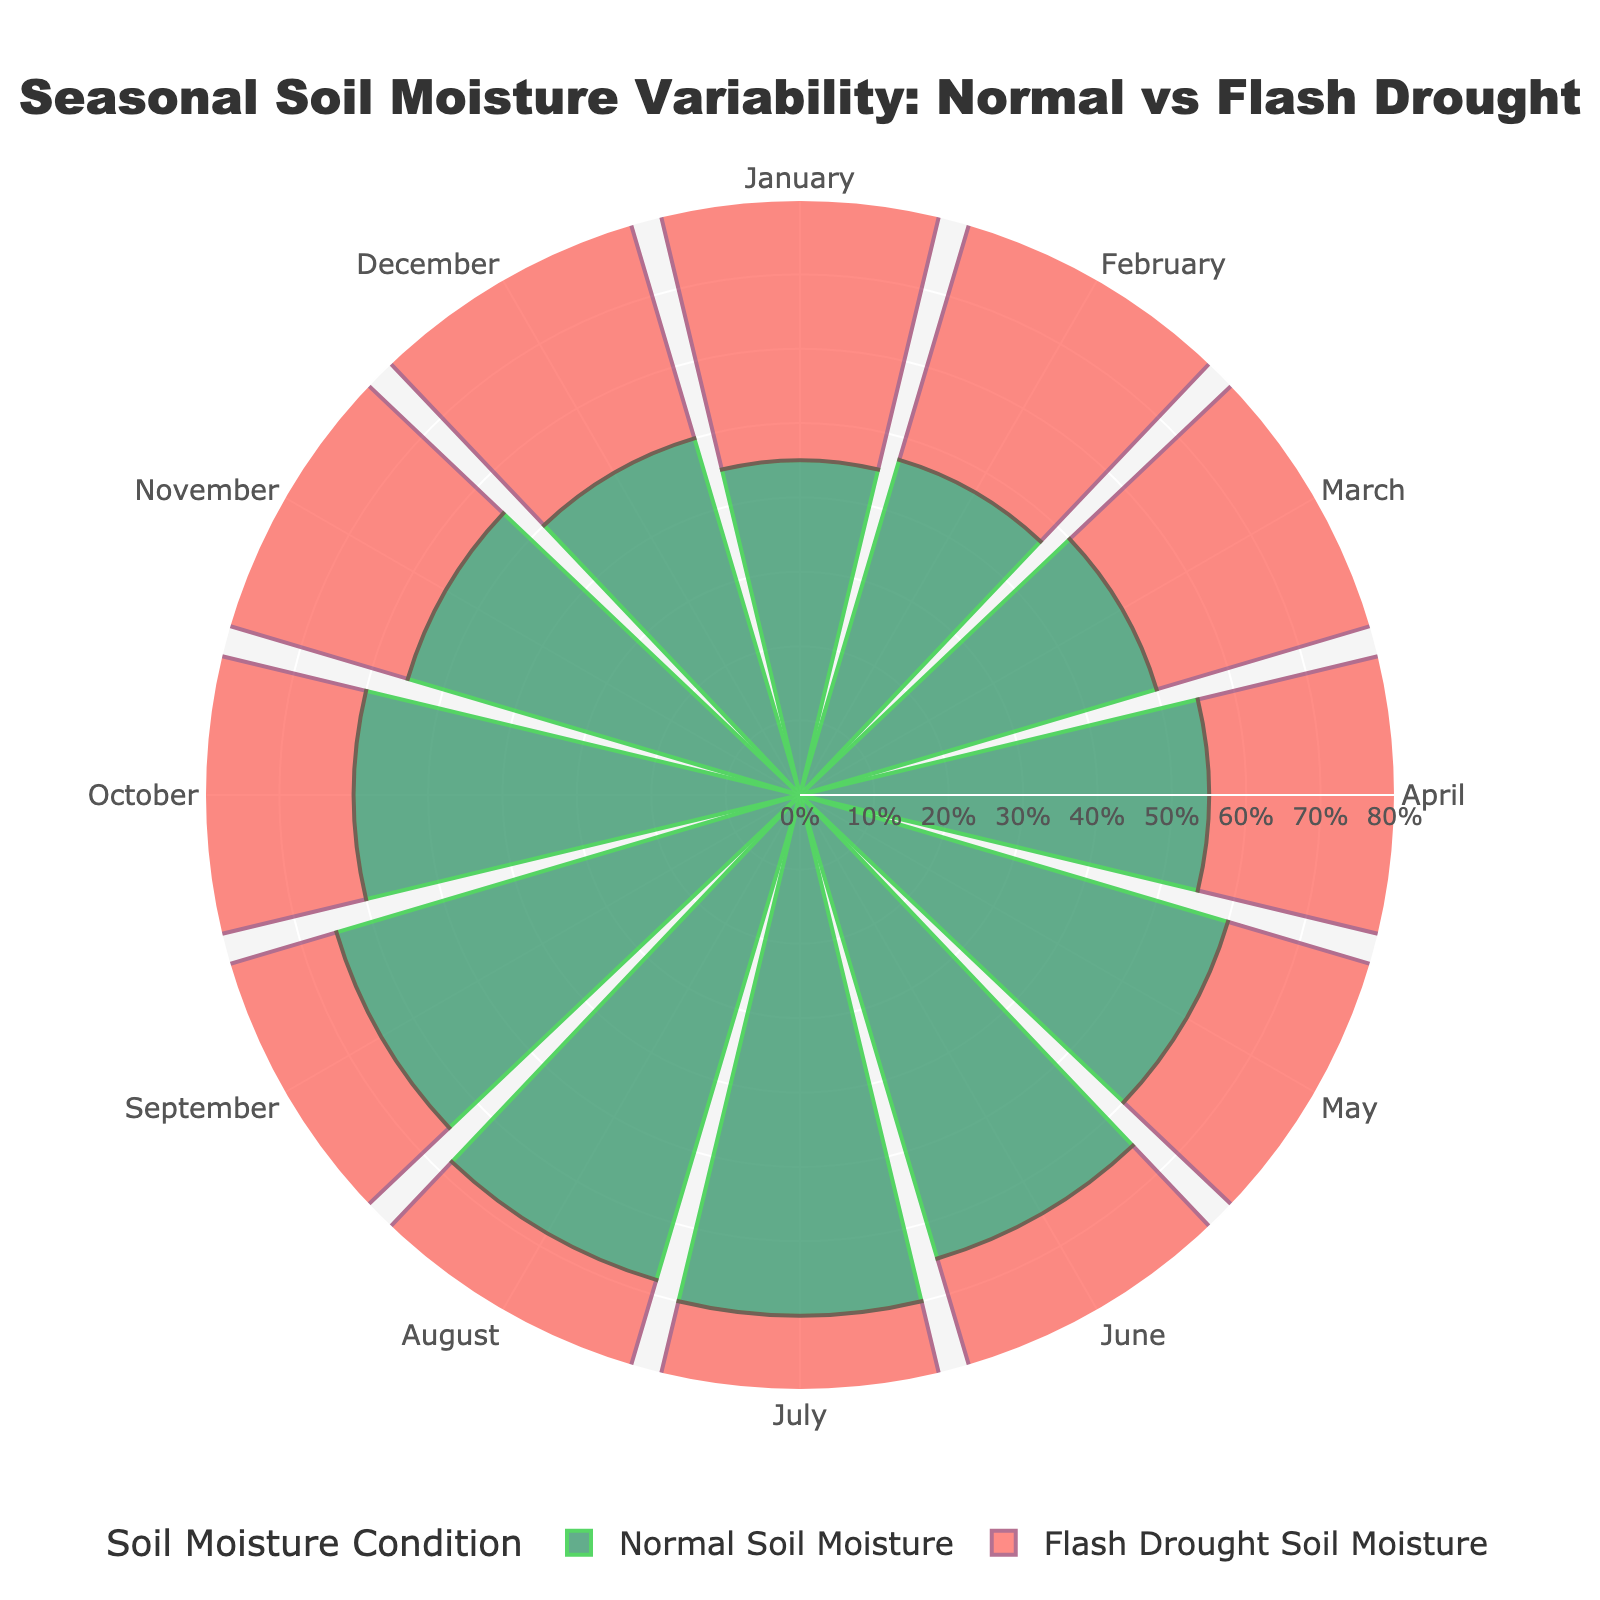How many months are displayed in the polar area chart? The chart shows data for each month of the year. By counting the distinct month labels around the circle, we can determine that there are 12 months displayed.
Answer: 12 What is the title of the polar area chart? The title is typically displayed prominently at the top of the chart. Here, it is "Seasonal Soil Moisture Variability: Normal vs Flash Drought".
Answer: Seasonal Soil Moisture Variability: Normal vs Flash Drought In which month is the difference between normal and flash drought soil moisture the largest? By comparing the bars for each month, July shows a substantial difference of 25% between normal (70%) and flash drought (45%) soil moisture.
Answer: July Which month shows the same soil moisture percentage for both normal and flash drought conditions? Looking at the bars for each month, January, February, March, April, November, and December all show equal lengths, indicating the same soil moisture percentage for both conditions.
Answer: January, February, March, April, November, December What is the soil moisture percentage in August during the flash drought? By finding the data point corresponding to August on the chart, the flash drought soil moisture is represented by a bar with a value of 40%.
Answer: 40% Which month has the highest normal soil moisture percentage? Observing the bars for normal conditions, July has the highest soil moisture percentage with a value of 70%.
Answer: July Calculate the average soil moisture percentage for the normal condition in summer months (June, July, August). First, locate the normal soil moisture values for June (65%), July (70%), and August (68%). Sum these values: 65 + 70 + 68 = 203. Divide by the number of months (3) to find the average: 203 / 3 = 67.67%.
Answer: 67.67% What is the range of soil moisture percentages for the flash drought condition throughout the year? Identify the minimum and maximum flash drought soil moisture values from the chart. The minimum is 40% (August), and the maximum is 55% (April, June, October, and November). The range is 55% - 40% = 15%.
Answer: 15% Compare the normal and flash drought soil moisture percentages for September and identify which condition has a higher percentage. For September, the normal soil moisture percentage is 65%, and the flash drought soil moisture percentage is 48%. Comparing these values, the normal condition is higher.
Answer: Normal Which three consecutive months show the greatest decline in soil moisture due to the flash drought? By examining the chart, the greatest decline is observed in June (65% to 55%), July (70% to 45%), and August (68% to 40%). Calculate the total change: (65 - 55) + (70 - 45) + (68 - 40) = 10 + 25 + 28 = 63%.
Answer: June, July, August 